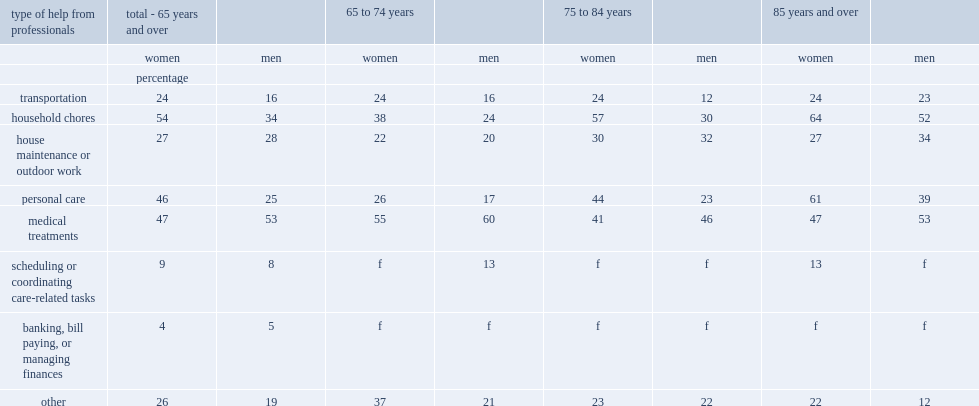What's the percentage of women aged 65 and over who received paid help reported receiving help with household chores, such as meal preparation and cleaning. 54.0. What were the second and third most frequently reported types of help received by senior women. Medical treatments personal care. Which was the most frequently reported by senior men was help with medical treatments. Medical treatments. 